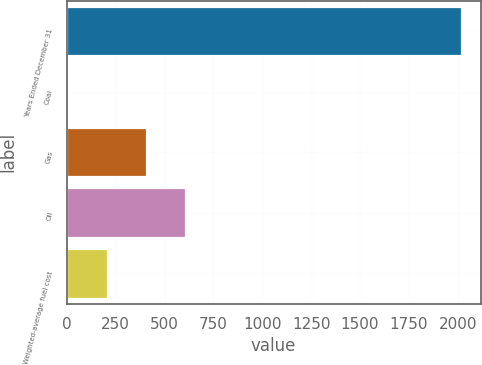<chart> <loc_0><loc_0><loc_500><loc_500><bar_chart><fcel>Years Ended December 31<fcel>Coal<fcel>Gas<fcel>Oil<fcel>Weighted-average fuel cost<nl><fcel>2016<fcel>2.4<fcel>405.12<fcel>606.48<fcel>203.76<nl></chart> 